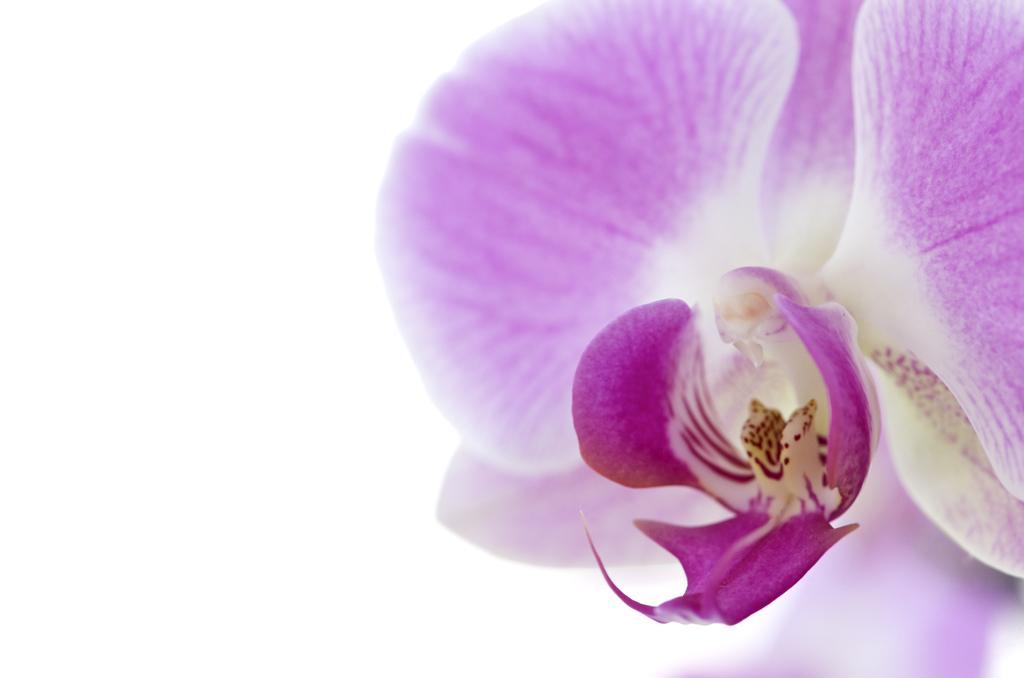How would you summarize this image in a sentence or two? In this image we can see a flower and we can also see white background. 